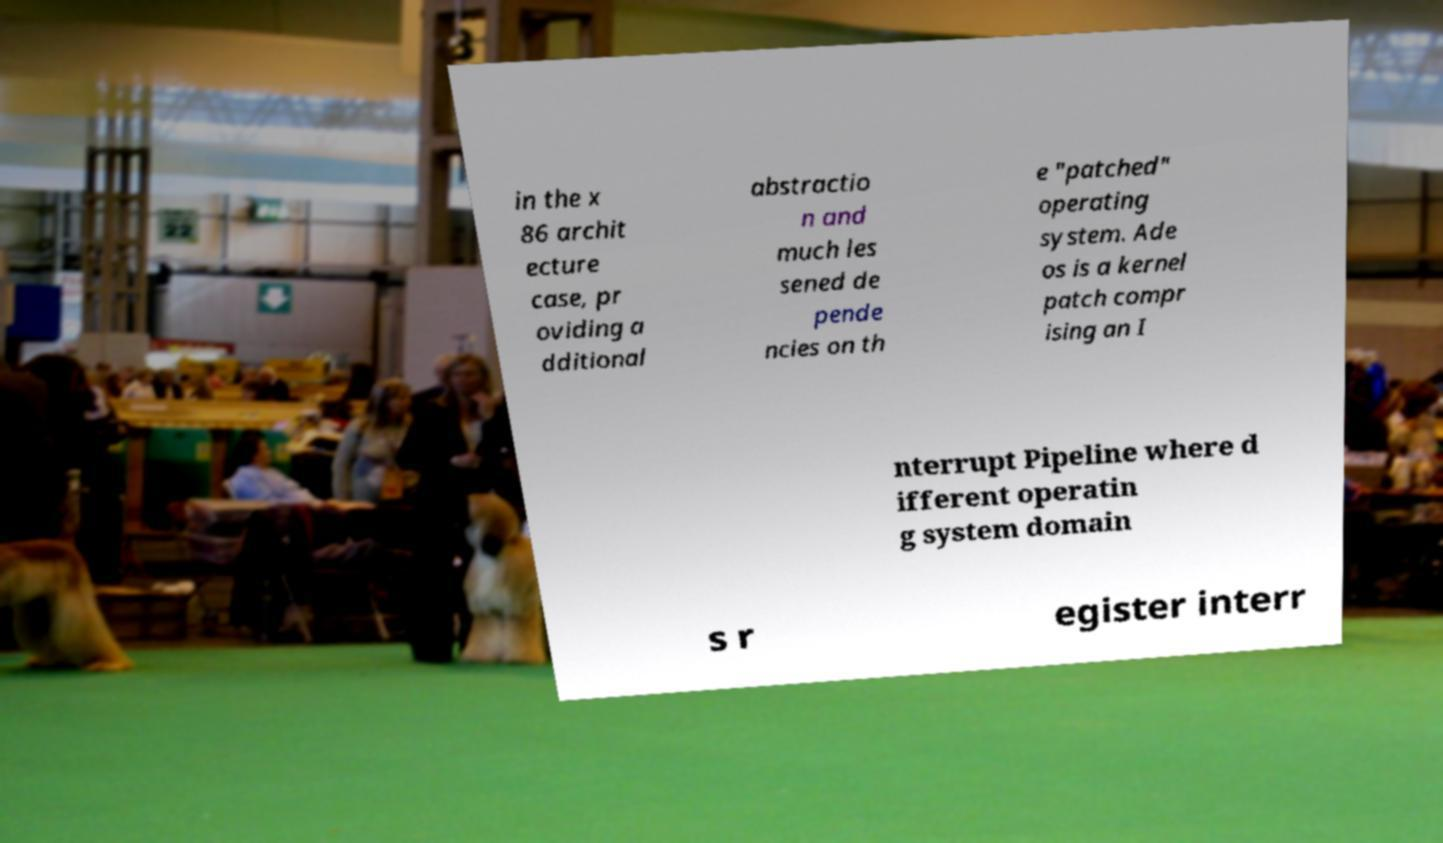Could you extract and type out the text from this image? in the x 86 archit ecture case, pr oviding a dditional abstractio n and much les sened de pende ncies on th e "patched" operating system. Ade os is a kernel patch compr ising an I nterrupt Pipeline where d ifferent operatin g system domain s r egister interr 